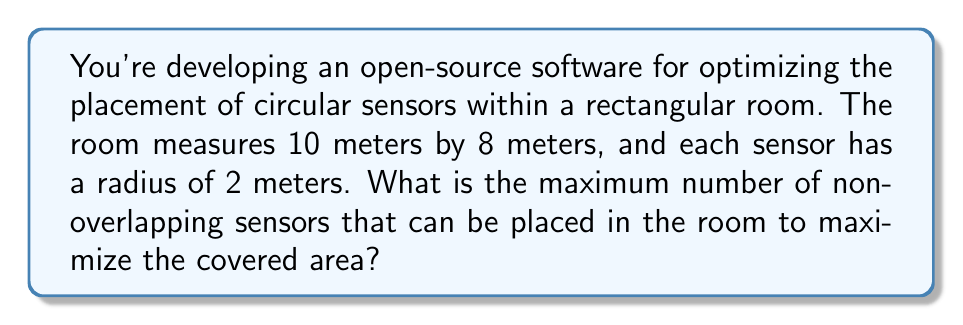Give your solution to this math problem. Let's approach this step-by-step:

1) First, we need to understand that the most efficient packing of circles in a plane is a hexagonal packing, where each circle is surrounded by six others.

2) In this arrangement, the centers of the circles form equilateral triangles. The distance between the centers of two adjacent circles is equal to the diameter of the circles.

3) The diameter of each sensor is $2r = 2 * 2 = 4$ meters.

4) For a 10m x 8m room, we can fit:
   - In the length: $\lfloor 10 / 4 \rfloor = 2$ full sensors
   - In the width: $\lfloor 8 / (4 * \sin 60°) \rfloor = \lfloor 8 / (4 * \frac{\sqrt{3}}{2}) \rfloor = 2$ rows

5) This forms a 2x2 grid of sensors, which gives us 4 sensors.

6) We can potentially fit one more sensor in the center of this grid:

   [asy]
   unitsize(10mm);
   defaultpen(fontsize(10pt));
   
   draw((0,0)--(10,0)--(10,8)--(0,8)--cycle);
   
   pair A = (2,2);
   pair B = (8,2);
   pair C = (2,6);
   pair D = (8,6);
   pair E = (5,4);
   
   draw(circle(A,2));
   draw(circle(B,2));
   draw(circle(C,2));
   draw(circle(D,2));
   draw(circle(E,2), dashed);
   
   label("10m", (5,0), S);
   label("8m", (0,4), W);
   [/asy]

7) The dashed circle in the center doesn't overlap with the others and fits within the room boundaries.

Therefore, the maximum number of non-overlapping sensors that can be placed in the room is 5.
Answer: 5 sensors 